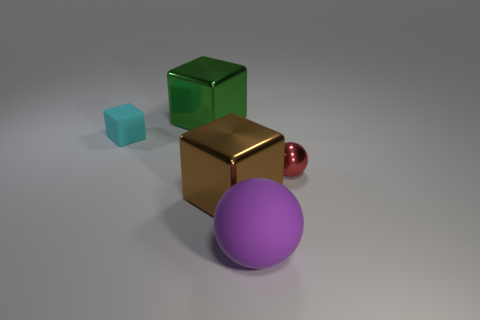How would you describe the lighting and shadow effects in this image? The image exhibits a soft overhead lighting that creates gentle shadows beneath the objects. These shadows are subtly diffused around the edges, indicating a light source that is not extremely harsh or direct. The way light reflects off the surfaces suggests a controlled environment, possibly used to highlight the object's materials and shapes. 